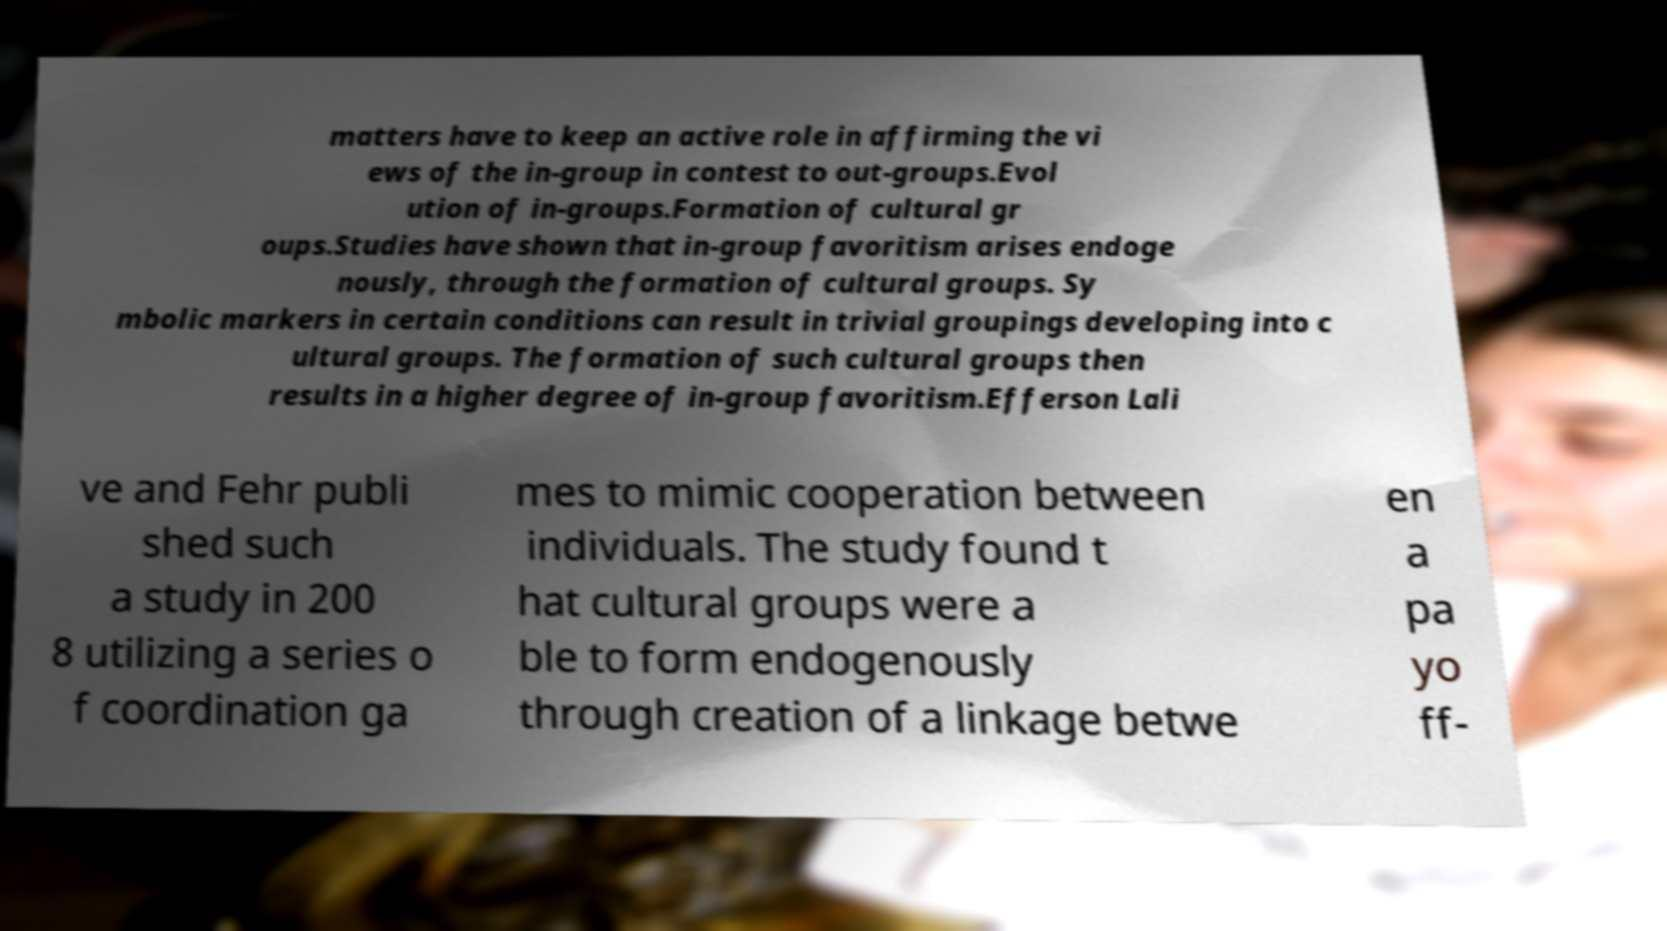What messages or text are displayed in this image? I need them in a readable, typed format. matters have to keep an active role in affirming the vi ews of the in-group in contest to out-groups.Evol ution of in-groups.Formation of cultural gr oups.Studies have shown that in-group favoritism arises endoge nously, through the formation of cultural groups. Sy mbolic markers in certain conditions can result in trivial groupings developing into c ultural groups. The formation of such cultural groups then results in a higher degree of in-group favoritism.Efferson Lali ve and Fehr publi shed such a study in 200 8 utilizing a series o f coordination ga mes to mimic cooperation between individuals. The study found t hat cultural groups were a ble to form endogenously through creation of a linkage betwe en a pa yo ff- 